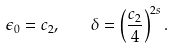<formula> <loc_0><loc_0><loc_500><loc_500>\epsilon _ { 0 } = c _ { 2 } , \quad \delta = \left ( \frac { c _ { 2 } } { 4 } \right ) ^ { 2 s } .</formula> 